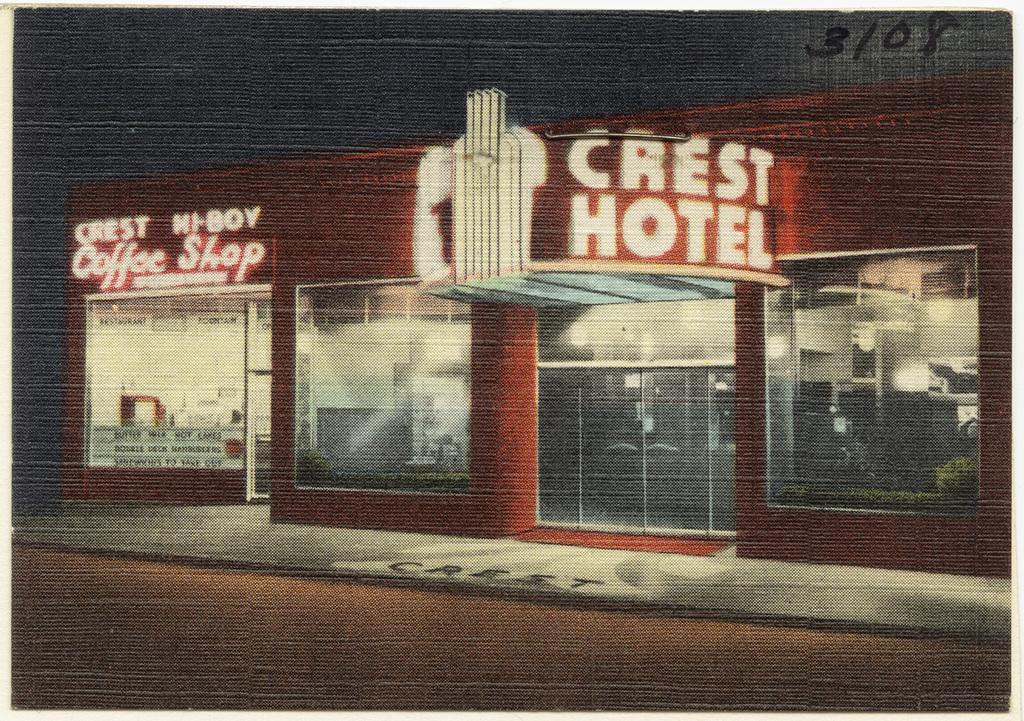Please provide a concise description of this image. In this picture I can see a poster, there is a building and there are numbers on the poster. 